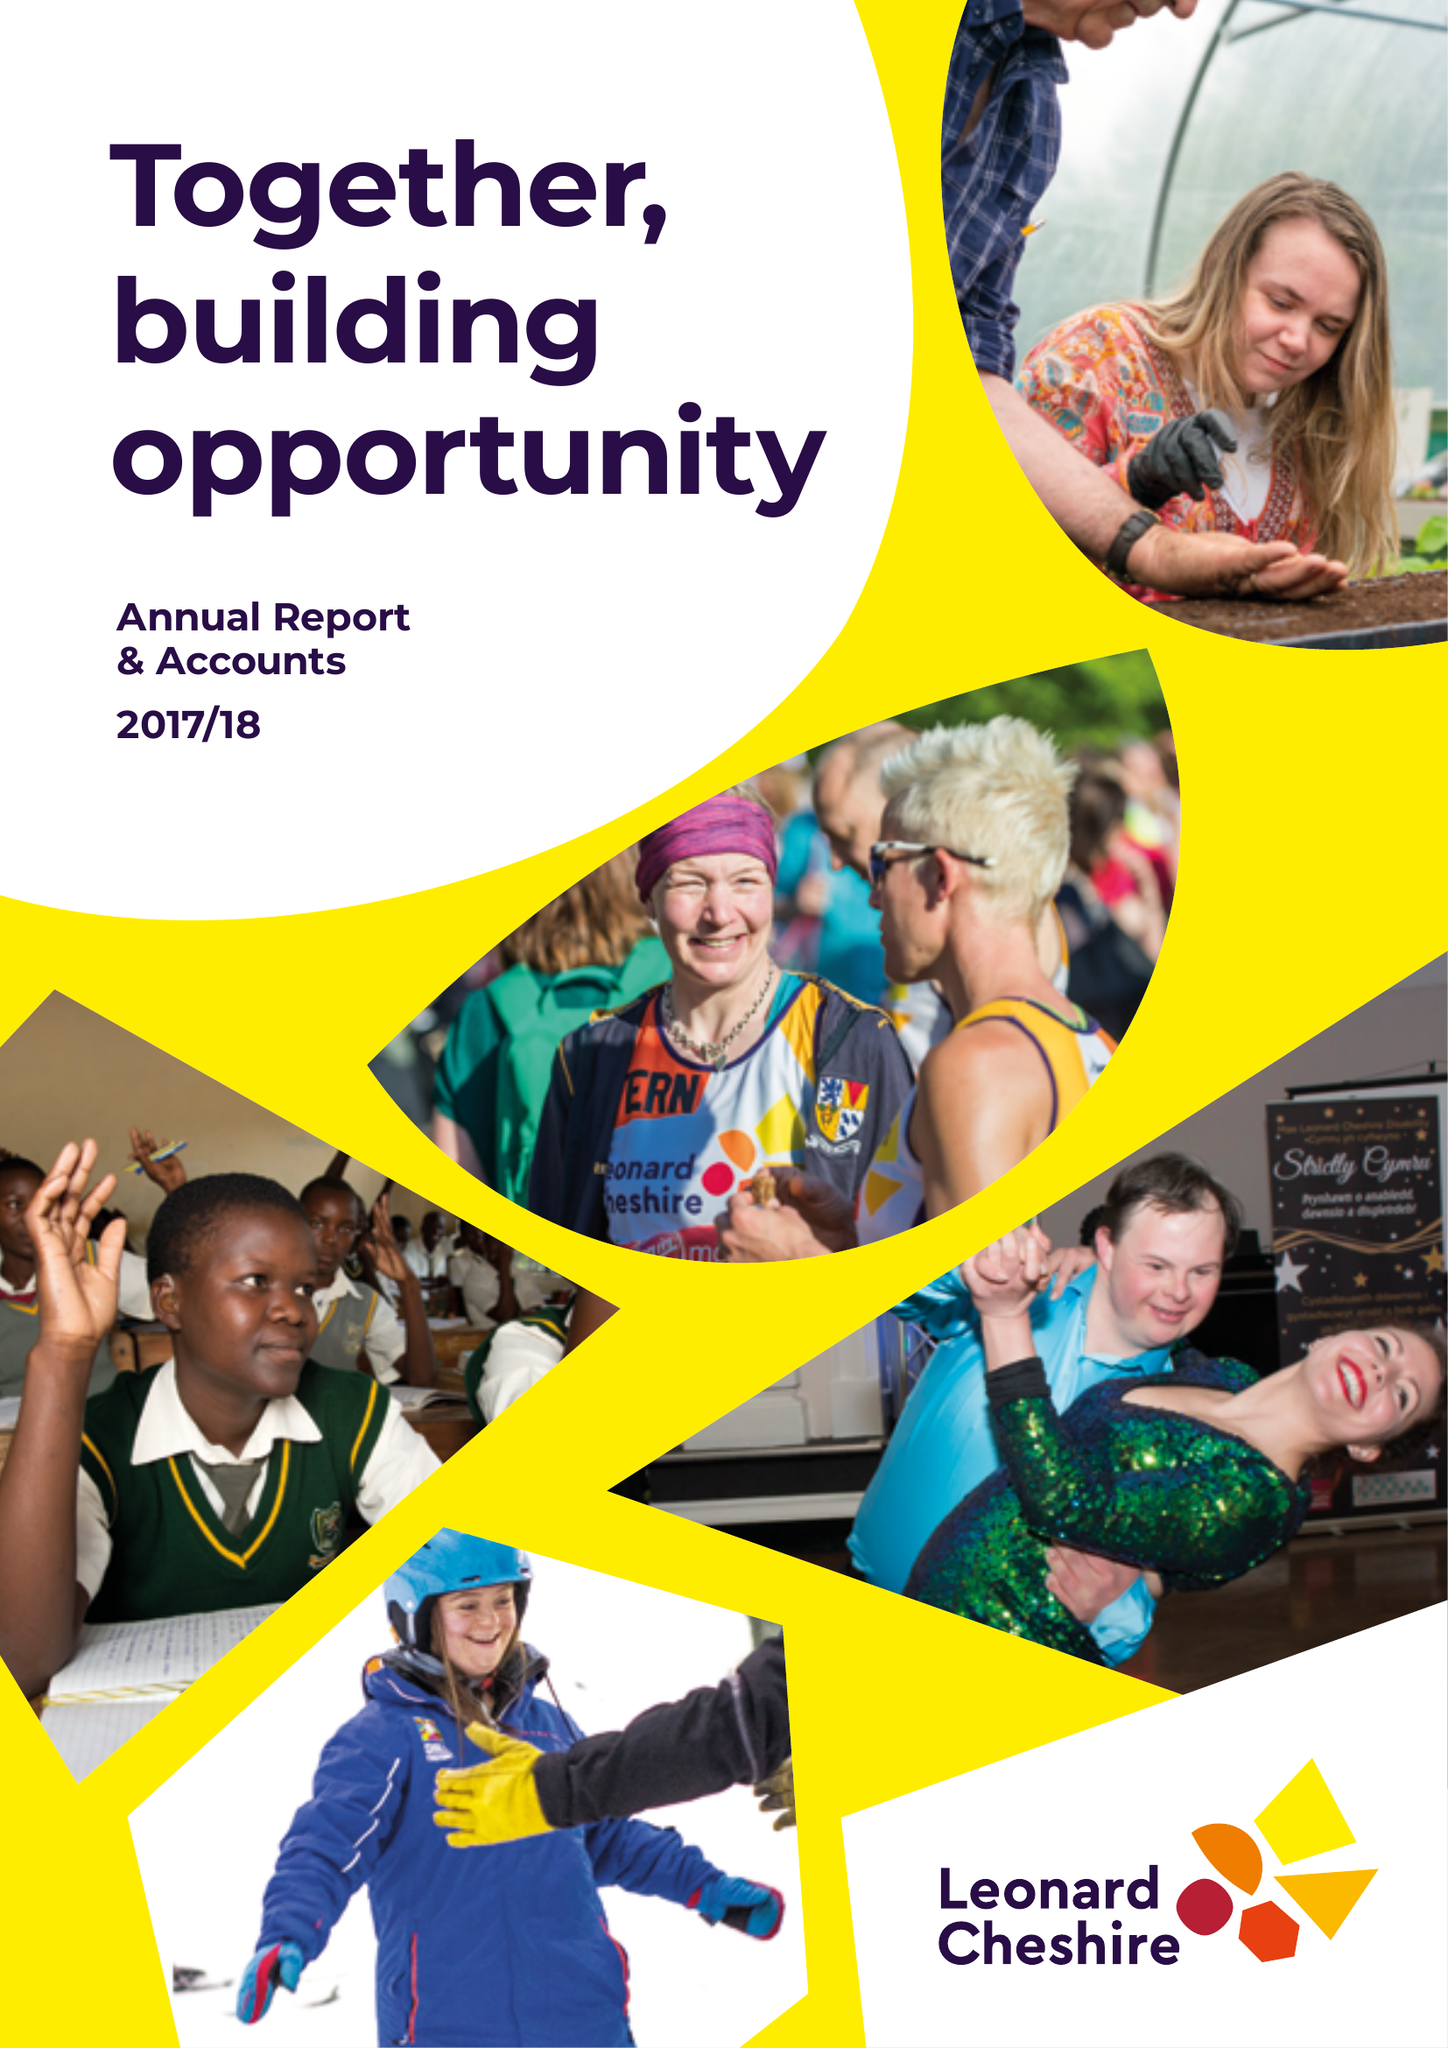What is the value for the address__post_town?
Answer the question using a single word or phrase. LONDON 